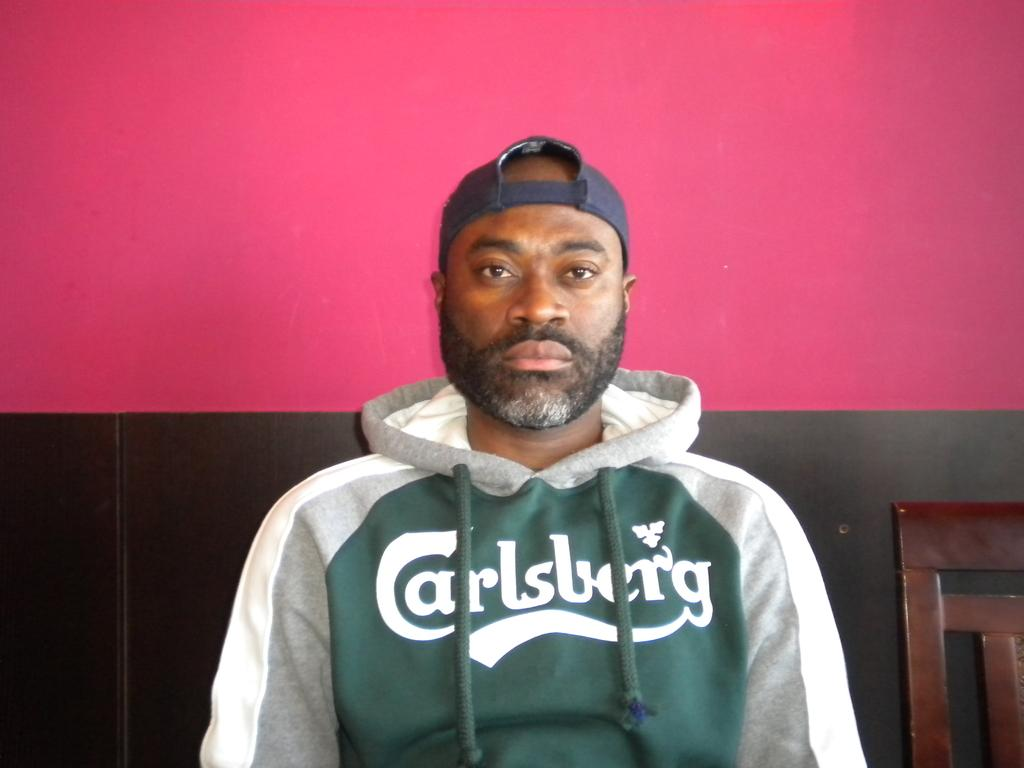Provide a one-sentence caption for the provided image. Green, gray, and white jacket with a Carlsberg logo wrote on front. 